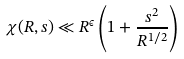<formula> <loc_0><loc_0><loc_500><loc_500>\chi ( R , s ) \ll R ^ { \epsilon } \left ( 1 + \frac { s ^ { 2 } } { R ^ { 1 / 2 } } \right )</formula> 